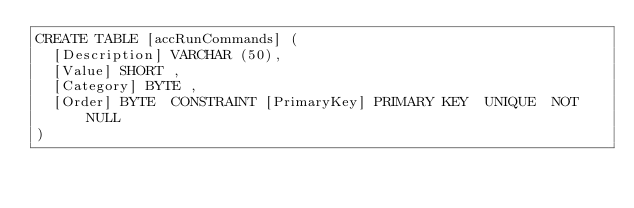Convert code to text. <code><loc_0><loc_0><loc_500><loc_500><_SQL_>CREATE TABLE [accRunCommands] (
  [Description] VARCHAR (50),
  [Value] SHORT ,
  [Category] BYTE ,
  [Order] BYTE  CONSTRAINT [PrimaryKey] PRIMARY KEY  UNIQUE  NOT NULL 
)
</code> 